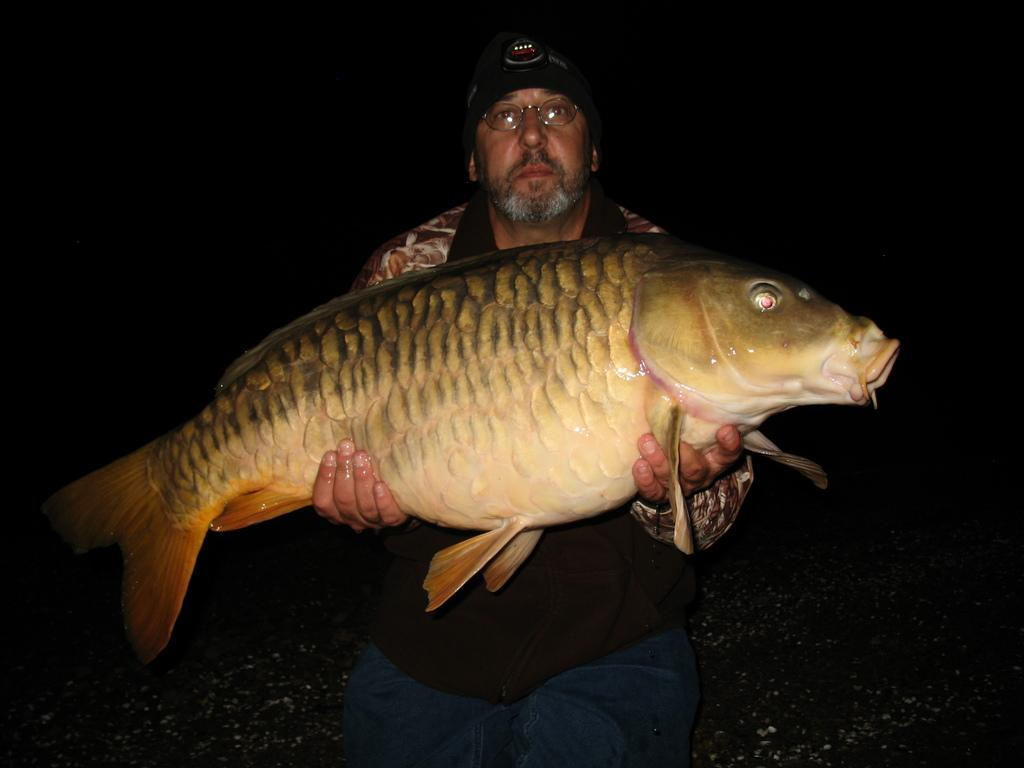Who is the main subject in the image? There is a man in the image. What is the man wearing on his head? The man is wearing a cap. What type of eyewear is the man wearing? The man is wearing spectacles. What is the man holding in his hands? The man is holding a fish with his hands. What can be observed about the lighting in the image? The background of the image is dark. What type of animal is the man riding in the image? There is no animal present in the image, and the man is not riding anything. 